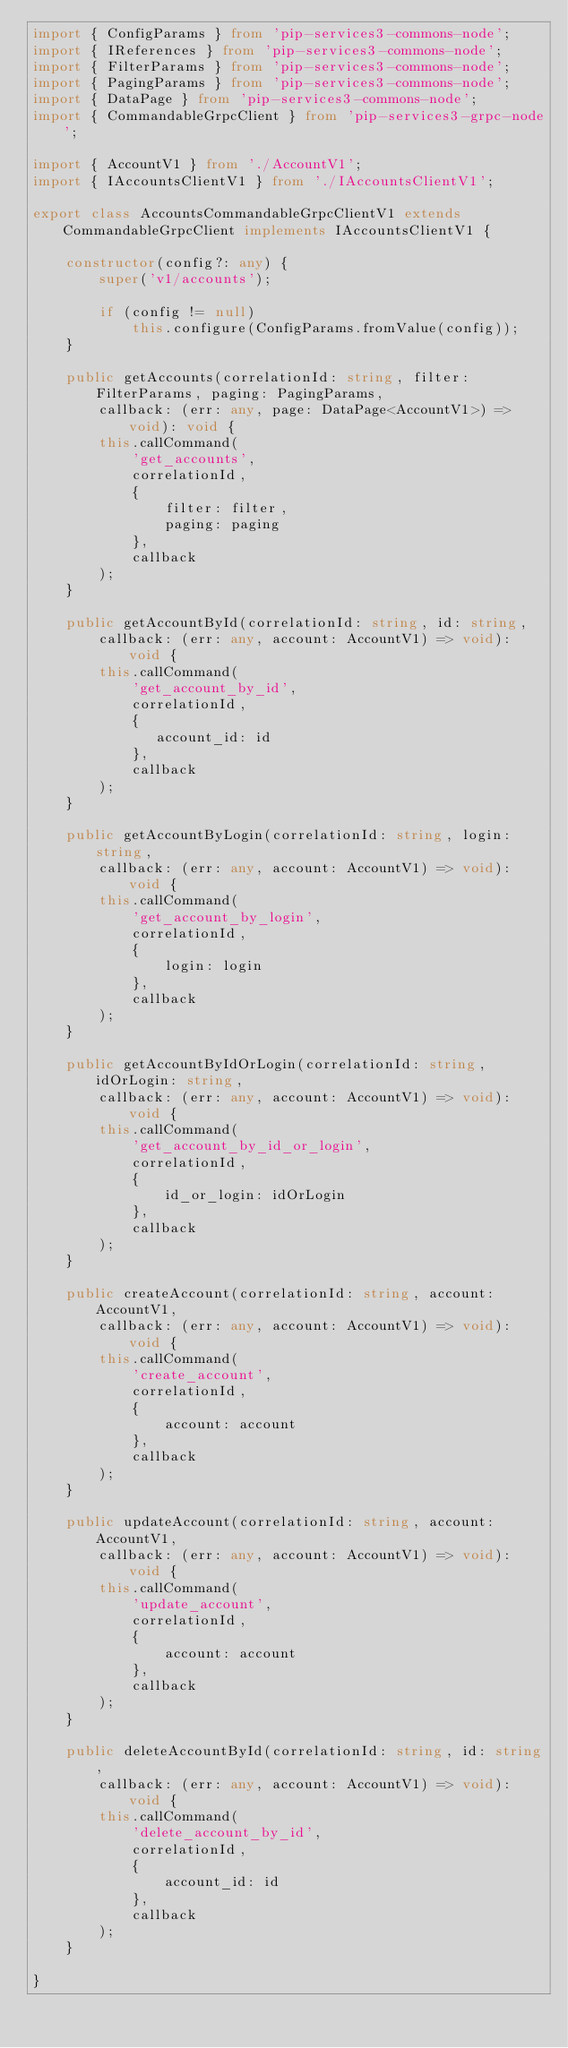<code> <loc_0><loc_0><loc_500><loc_500><_TypeScript_>import { ConfigParams } from 'pip-services3-commons-node';
import { IReferences } from 'pip-services3-commons-node';
import { FilterParams } from 'pip-services3-commons-node';
import { PagingParams } from 'pip-services3-commons-node';
import { DataPage } from 'pip-services3-commons-node';
import { CommandableGrpcClient } from 'pip-services3-grpc-node';

import { AccountV1 } from './AccountV1';
import { IAccountsClientV1 } from './IAccountsClientV1';

export class AccountsCommandableGrpcClientV1 extends CommandableGrpcClient implements IAccountsClientV1 {

    constructor(config?: any) {
        super('v1/accounts');

        if (config != null)
            this.configure(ConfigParams.fromValue(config));
    }

    public getAccounts(correlationId: string, filter: FilterParams, paging: PagingParams,
        callback: (err: any, page: DataPage<AccountV1>) => void): void {
        this.callCommand(
            'get_accounts',
            correlationId,
            {
                filter: filter,
                paging: paging
            },
            callback
        );
    }

    public getAccountById(correlationId: string, id: string,
        callback: (err: any, account: AccountV1) => void): void {
        this.callCommand(
            'get_account_by_id',
            correlationId,
            {
               account_id: id
            },
            callback
        );
    }

    public getAccountByLogin(correlationId: string, login: string,
        callback: (err: any, account: AccountV1) => void): void {
        this.callCommand(
            'get_account_by_login',
            correlationId,
            {
                login: login
            },
            callback
        );
    }

    public getAccountByIdOrLogin(correlationId: string, idOrLogin: string,
        callback: (err: any, account: AccountV1) => void): void {
        this.callCommand(
            'get_account_by_id_or_login',
            correlationId,
            {
                id_or_login: idOrLogin
            },
            callback
        );
    }

    public createAccount(correlationId: string, account: AccountV1,
        callback: (err: any, account: AccountV1) => void): void {
        this.callCommand(
            'create_account',
            correlationId,
            {
                account: account
            },
            callback
        );
    }

    public updateAccount(correlationId: string, account: AccountV1,
        callback: (err: any, account: AccountV1) => void): void {
        this.callCommand(
            'update_account',
            correlationId,
            {
                account: account
            },
            callback
        );
    }

    public deleteAccountById(correlationId: string, id: string,
        callback: (err: any, account: AccountV1) => void): void {
        this.callCommand(
            'delete_account_by_id',
            correlationId,
            {
                account_id: id
            },
            callback
        );
    }

}
</code> 